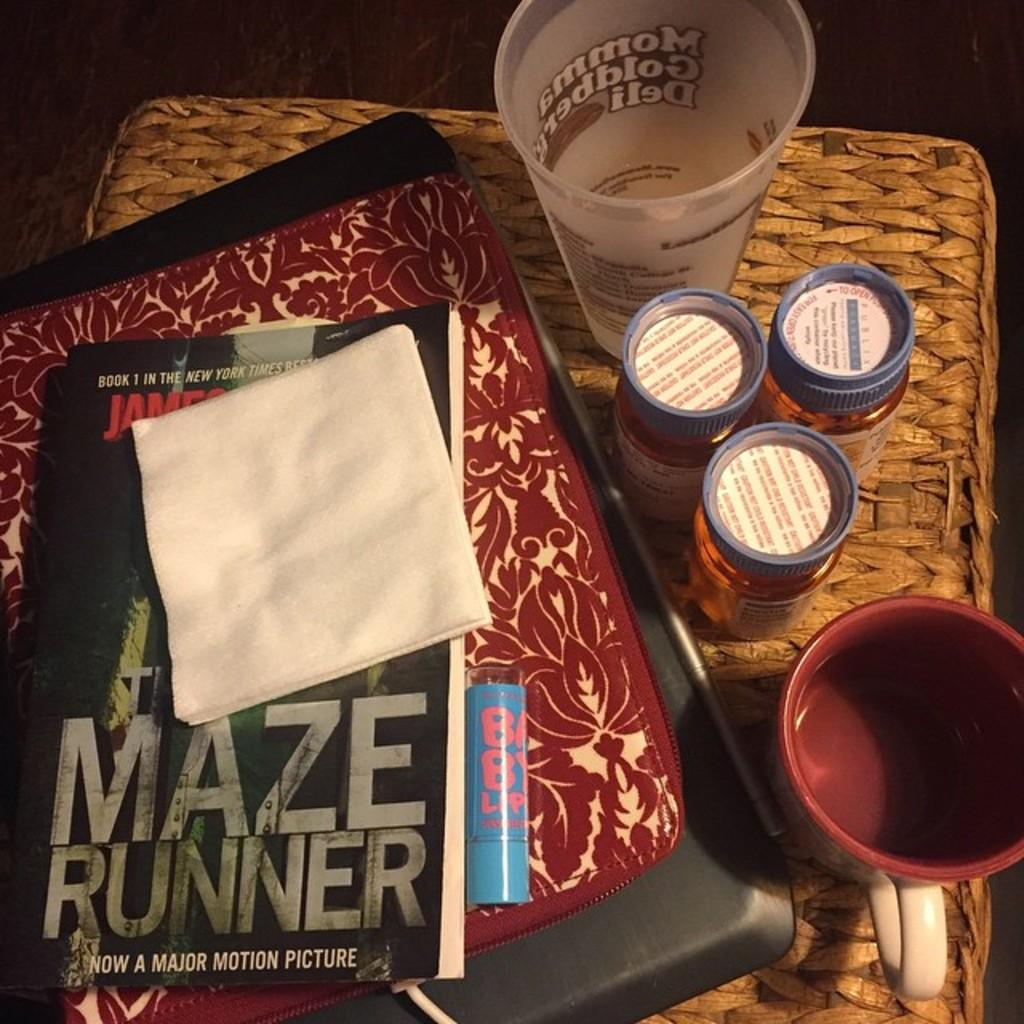<image>
Describe the image concisely. The book Maze Runner is now a major motion picture. 